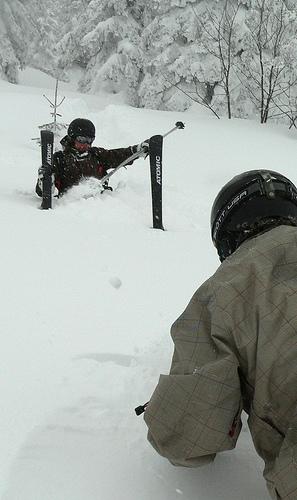Is this man happy?
Answer briefly. No. Is one of them stuck in the snow?
Keep it brief. Yes. How many are in this image?
Concise answer only. 2. How difficult will it be to get back up?
Write a very short answer. Very. 